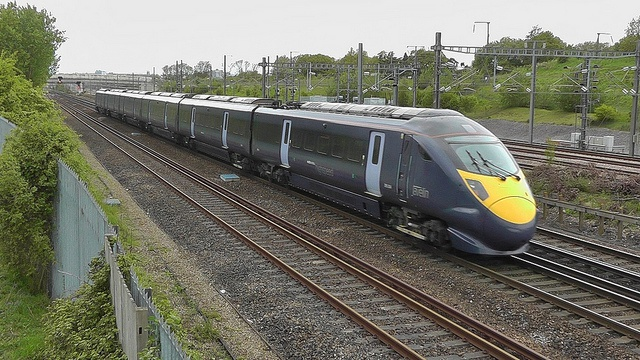Describe the objects in this image and their specific colors. I can see a train in white, black, gray, darkgray, and lightgray tones in this image. 